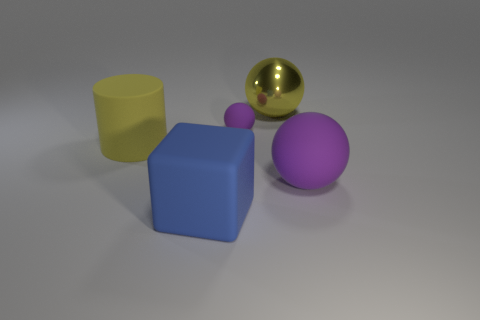Are there any other things that are the same material as the big yellow ball?
Your answer should be compact. No. Is the number of yellow metallic objects greater than the number of big things?
Offer a very short reply. No. Are any big purple balls visible?
Your answer should be compact. Yes. There is a purple thing in front of the yellow object left of the tiny object; what shape is it?
Ensure brevity in your answer.  Sphere. How many objects are matte things or large purple spheres behind the cube?
Your answer should be very brief. 4. There is a large rubber object on the right side of the large ball that is behind the yellow thing that is left of the large blue object; what color is it?
Offer a very short reply. Purple. What material is the other small purple object that is the same shape as the metallic object?
Give a very brief answer. Rubber. What is the color of the rubber cylinder?
Provide a short and direct response. Yellow. Is the color of the large matte block the same as the rubber cylinder?
Your response must be concise. No. How many shiny things are tiny things or large purple things?
Your answer should be very brief. 0. 